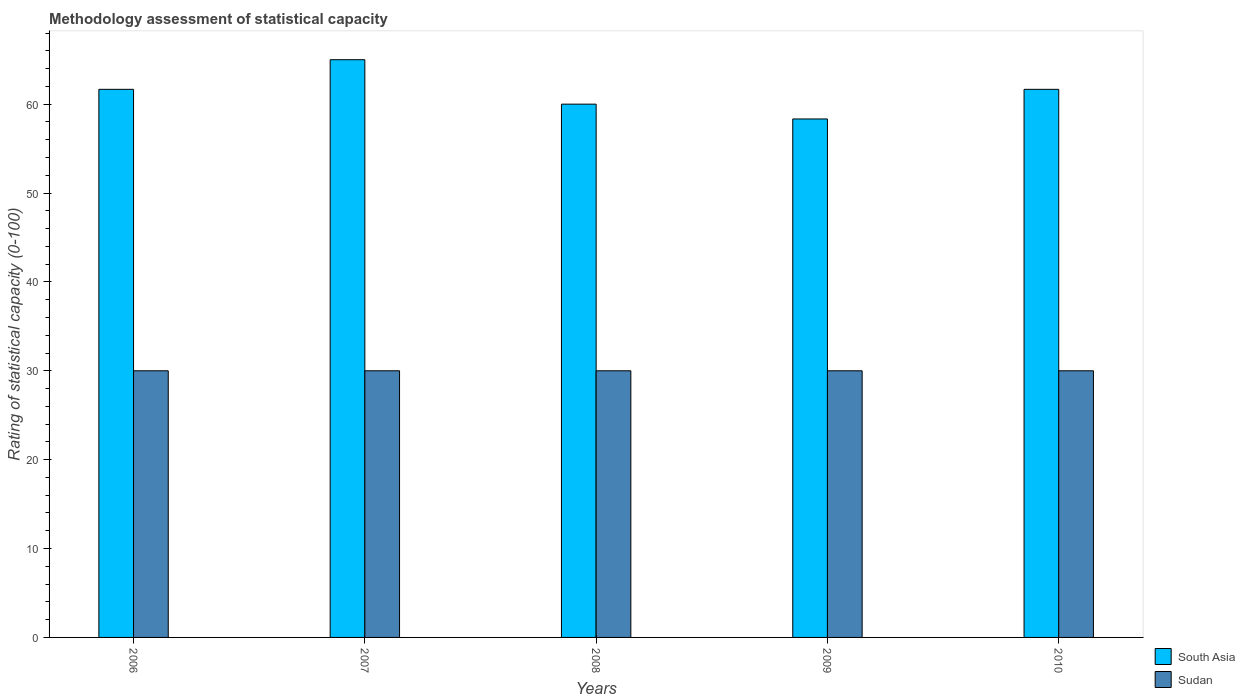How many bars are there on the 2nd tick from the left?
Provide a short and direct response. 2. What is the label of the 2nd group of bars from the left?
Provide a short and direct response. 2007. In how many cases, is the number of bars for a given year not equal to the number of legend labels?
Your response must be concise. 0. What is the rating of statistical capacity in South Asia in 2010?
Your answer should be very brief. 61.67. Across all years, what is the maximum rating of statistical capacity in South Asia?
Offer a very short reply. 65. Across all years, what is the minimum rating of statistical capacity in Sudan?
Give a very brief answer. 30. In which year was the rating of statistical capacity in South Asia maximum?
Provide a succinct answer. 2007. What is the total rating of statistical capacity in Sudan in the graph?
Make the answer very short. 150. What is the difference between the rating of statistical capacity in Sudan in 2007 and that in 2008?
Your answer should be very brief. 0. What is the difference between the rating of statistical capacity in Sudan in 2007 and the rating of statistical capacity in South Asia in 2010?
Make the answer very short. -31.67. What is the average rating of statistical capacity in South Asia per year?
Ensure brevity in your answer.  61.33. In the year 2007, what is the difference between the rating of statistical capacity in Sudan and rating of statistical capacity in South Asia?
Keep it short and to the point. -35. What is the difference between the highest and the second highest rating of statistical capacity in Sudan?
Offer a terse response. 0. What is the difference between the highest and the lowest rating of statistical capacity in Sudan?
Make the answer very short. 0. Is the sum of the rating of statistical capacity in Sudan in 2008 and 2010 greater than the maximum rating of statistical capacity in South Asia across all years?
Make the answer very short. No. What does the 2nd bar from the left in 2009 represents?
Ensure brevity in your answer.  Sudan. What does the 1st bar from the right in 2008 represents?
Make the answer very short. Sudan. Are all the bars in the graph horizontal?
Your answer should be compact. No. How many years are there in the graph?
Ensure brevity in your answer.  5. Are the values on the major ticks of Y-axis written in scientific E-notation?
Provide a short and direct response. No. Where does the legend appear in the graph?
Make the answer very short. Bottom right. How many legend labels are there?
Offer a terse response. 2. How are the legend labels stacked?
Provide a short and direct response. Vertical. What is the title of the graph?
Keep it short and to the point. Methodology assessment of statistical capacity. What is the label or title of the X-axis?
Offer a terse response. Years. What is the label or title of the Y-axis?
Make the answer very short. Rating of statistical capacity (0-100). What is the Rating of statistical capacity (0-100) in South Asia in 2006?
Offer a very short reply. 61.67. What is the Rating of statistical capacity (0-100) of Sudan in 2007?
Your response must be concise. 30. What is the Rating of statistical capacity (0-100) in South Asia in 2008?
Your answer should be compact. 60. What is the Rating of statistical capacity (0-100) in Sudan in 2008?
Offer a terse response. 30. What is the Rating of statistical capacity (0-100) of South Asia in 2009?
Ensure brevity in your answer.  58.33. What is the Rating of statistical capacity (0-100) of Sudan in 2009?
Your answer should be very brief. 30. What is the Rating of statistical capacity (0-100) in South Asia in 2010?
Offer a terse response. 61.67. Across all years, what is the maximum Rating of statistical capacity (0-100) of South Asia?
Ensure brevity in your answer.  65. Across all years, what is the minimum Rating of statistical capacity (0-100) of South Asia?
Your answer should be compact. 58.33. What is the total Rating of statistical capacity (0-100) in South Asia in the graph?
Offer a very short reply. 306.67. What is the total Rating of statistical capacity (0-100) of Sudan in the graph?
Make the answer very short. 150. What is the difference between the Rating of statistical capacity (0-100) in South Asia in 2006 and that in 2008?
Ensure brevity in your answer.  1.67. What is the difference between the Rating of statistical capacity (0-100) in Sudan in 2006 and that in 2008?
Give a very brief answer. 0. What is the difference between the Rating of statistical capacity (0-100) in South Asia in 2006 and that in 2010?
Make the answer very short. 0. What is the difference between the Rating of statistical capacity (0-100) in Sudan in 2007 and that in 2009?
Offer a very short reply. 0. What is the difference between the Rating of statistical capacity (0-100) of South Asia in 2007 and that in 2010?
Make the answer very short. 3.33. What is the difference between the Rating of statistical capacity (0-100) in Sudan in 2008 and that in 2009?
Provide a short and direct response. 0. What is the difference between the Rating of statistical capacity (0-100) of South Asia in 2008 and that in 2010?
Offer a terse response. -1.67. What is the difference between the Rating of statistical capacity (0-100) in South Asia in 2009 and that in 2010?
Offer a very short reply. -3.33. What is the difference between the Rating of statistical capacity (0-100) in Sudan in 2009 and that in 2010?
Ensure brevity in your answer.  0. What is the difference between the Rating of statistical capacity (0-100) in South Asia in 2006 and the Rating of statistical capacity (0-100) in Sudan in 2007?
Ensure brevity in your answer.  31.67. What is the difference between the Rating of statistical capacity (0-100) in South Asia in 2006 and the Rating of statistical capacity (0-100) in Sudan in 2008?
Offer a terse response. 31.67. What is the difference between the Rating of statistical capacity (0-100) of South Asia in 2006 and the Rating of statistical capacity (0-100) of Sudan in 2009?
Provide a short and direct response. 31.67. What is the difference between the Rating of statistical capacity (0-100) of South Asia in 2006 and the Rating of statistical capacity (0-100) of Sudan in 2010?
Your answer should be very brief. 31.67. What is the difference between the Rating of statistical capacity (0-100) of South Asia in 2007 and the Rating of statistical capacity (0-100) of Sudan in 2010?
Keep it short and to the point. 35. What is the difference between the Rating of statistical capacity (0-100) of South Asia in 2008 and the Rating of statistical capacity (0-100) of Sudan in 2009?
Give a very brief answer. 30. What is the difference between the Rating of statistical capacity (0-100) of South Asia in 2008 and the Rating of statistical capacity (0-100) of Sudan in 2010?
Keep it short and to the point. 30. What is the difference between the Rating of statistical capacity (0-100) in South Asia in 2009 and the Rating of statistical capacity (0-100) in Sudan in 2010?
Offer a terse response. 28.33. What is the average Rating of statistical capacity (0-100) of South Asia per year?
Keep it short and to the point. 61.33. In the year 2006, what is the difference between the Rating of statistical capacity (0-100) of South Asia and Rating of statistical capacity (0-100) of Sudan?
Your response must be concise. 31.67. In the year 2008, what is the difference between the Rating of statistical capacity (0-100) of South Asia and Rating of statistical capacity (0-100) of Sudan?
Make the answer very short. 30. In the year 2009, what is the difference between the Rating of statistical capacity (0-100) of South Asia and Rating of statistical capacity (0-100) of Sudan?
Provide a short and direct response. 28.33. In the year 2010, what is the difference between the Rating of statistical capacity (0-100) of South Asia and Rating of statistical capacity (0-100) of Sudan?
Provide a short and direct response. 31.67. What is the ratio of the Rating of statistical capacity (0-100) in South Asia in 2006 to that in 2007?
Provide a short and direct response. 0.95. What is the ratio of the Rating of statistical capacity (0-100) of Sudan in 2006 to that in 2007?
Give a very brief answer. 1. What is the ratio of the Rating of statistical capacity (0-100) in South Asia in 2006 to that in 2008?
Your response must be concise. 1.03. What is the ratio of the Rating of statistical capacity (0-100) in South Asia in 2006 to that in 2009?
Give a very brief answer. 1.06. What is the ratio of the Rating of statistical capacity (0-100) in Sudan in 2006 to that in 2009?
Provide a succinct answer. 1. What is the ratio of the Rating of statistical capacity (0-100) in South Asia in 2006 to that in 2010?
Give a very brief answer. 1. What is the ratio of the Rating of statistical capacity (0-100) in South Asia in 2007 to that in 2008?
Your answer should be very brief. 1.08. What is the ratio of the Rating of statistical capacity (0-100) in Sudan in 2007 to that in 2008?
Provide a succinct answer. 1. What is the ratio of the Rating of statistical capacity (0-100) in South Asia in 2007 to that in 2009?
Your answer should be very brief. 1.11. What is the ratio of the Rating of statistical capacity (0-100) of South Asia in 2007 to that in 2010?
Give a very brief answer. 1.05. What is the ratio of the Rating of statistical capacity (0-100) of South Asia in 2008 to that in 2009?
Your answer should be compact. 1.03. What is the ratio of the Rating of statistical capacity (0-100) of South Asia in 2009 to that in 2010?
Offer a very short reply. 0.95. What is the difference between the highest and the second highest Rating of statistical capacity (0-100) in Sudan?
Your response must be concise. 0. What is the difference between the highest and the lowest Rating of statistical capacity (0-100) of South Asia?
Offer a terse response. 6.67. What is the difference between the highest and the lowest Rating of statistical capacity (0-100) of Sudan?
Your answer should be compact. 0. 